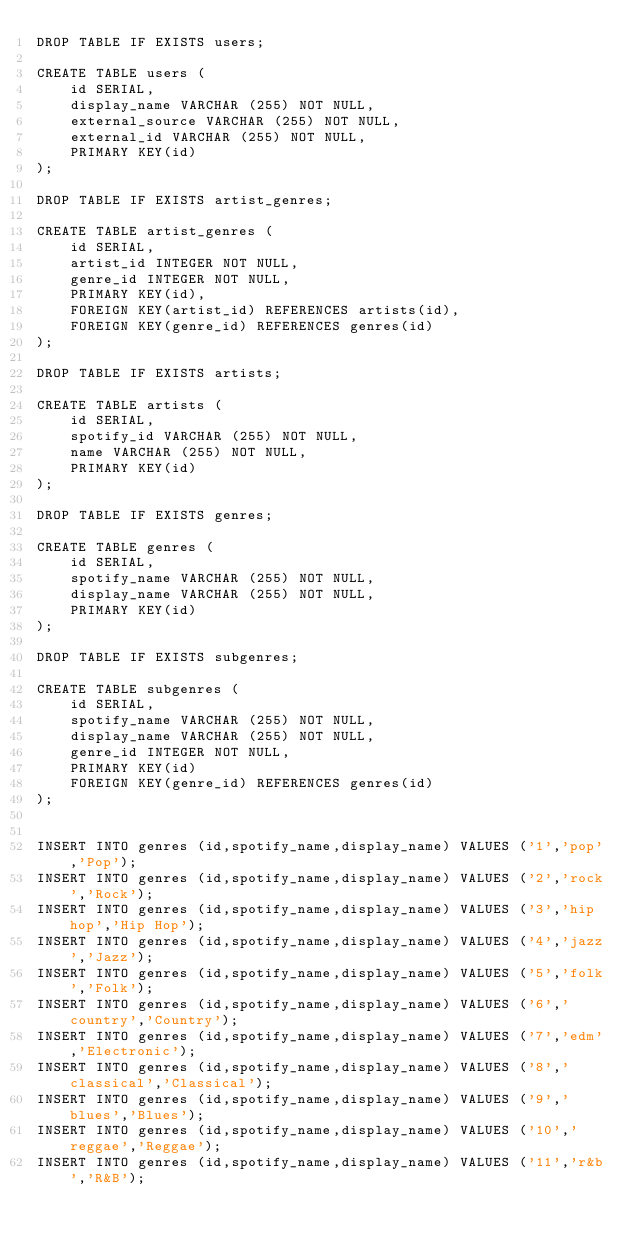<code> <loc_0><loc_0><loc_500><loc_500><_SQL_>DROP TABLE IF EXISTS users;

CREATE TABLE users (
    id SERIAL,
    display_name VARCHAR (255) NOT NULL,
    external_source VARCHAR (255) NOT NULL,
    external_id VARCHAR (255) NOT NULL,
    PRIMARY KEY(id)
);

DROP TABLE IF EXISTS artist_genres;

CREATE TABLE artist_genres (
    id SERIAL,
    artist_id INTEGER NOT NULL,
    genre_id INTEGER NOT NULL,
    PRIMARY KEY(id),
    FOREIGN KEY(artist_id) REFERENCES artists(id),
    FOREIGN KEY(genre_id) REFERENCES genres(id)
);

DROP TABLE IF EXISTS artists;

CREATE TABLE artists (
    id SERIAL,
    spotify_id VARCHAR (255) NOT NULL,
    name VARCHAR (255) NOT NULL,
    PRIMARY KEY(id)
);

DROP TABLE IF EXISTS genres;

CREATE TABLE genres (
    id SERIAL,
    spotify_name VARCHAR (255) NOT NULL,
    display_name VARCHAR (255) NOT NULL,
    PRIMARY KEY(id)
);

DROP TABLE IF EXISTS subgenres;

CREATE TABLE subgenres (
    id SERIAL,
    spotify_name VARCHAR (255) NOT NULL,
    display_name VARCHAR (255) NOT NULL,
    genre_id INTEGER NOT NULL,
    PRIMARY KEY(id)
    FOREIGN KEY(genre_id) REFERENCES genres(id)
);


INSERT INTO genres (id,spotify_name,display_name) VALUES ('1','pop','Pop');
INSERT INTO genres (id,spotify_name,display_name) VALUES ('2','rock','Rock');
INSERT INTO genres (id,spotify_name,display_name) VALUES ('3','hip hop','Hip Hop');
INSERT INTO genres (id,spotify_name,display_name) VALUES ('4','jazz','Jazz');
INSERT INTO genres (id,spotify_name,display_name) VALUES ('5','folk','Folk');
INSERT INTO genres (id,spotify_name,display_name) VALUES ('6','country','Country');
INSERT INTO genres (id,spotify_name,display_name) VALUES ('7','edm','Electronic');
INSERT INTO genres (id,spotify_name,display_name) VALUES ('8','classical','Classical');
INSERT INTO genres (id,spotify_name,display_name) VALUES ('9','blues','Blues');
INSERT INTO genres (id,spotify_name,display_name) VALUES ('10','reggae','Reggae');
INSERT INTO genres (id,spotify_name,display_name) VALUES ('11','r&b','R&B');
</code> 